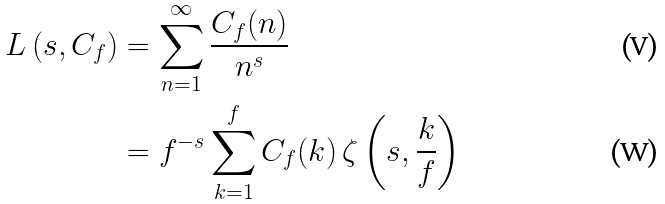Convert formula to latex. <formula><loc_0><loc_0><loc_500><loc_500>L \left ( s , C _ { f } \right ) & = \sum _ { n = 1 } ^ { \infty } \frac { C _ { f } ( n ) } { n ^ { s } } \\ & = f ^ { - s } \sum _ { k = 1 } ^ { f } C _ { f } ( k ) \, \zeta \left ( s , \frac { k } { f } \right )</formula> 